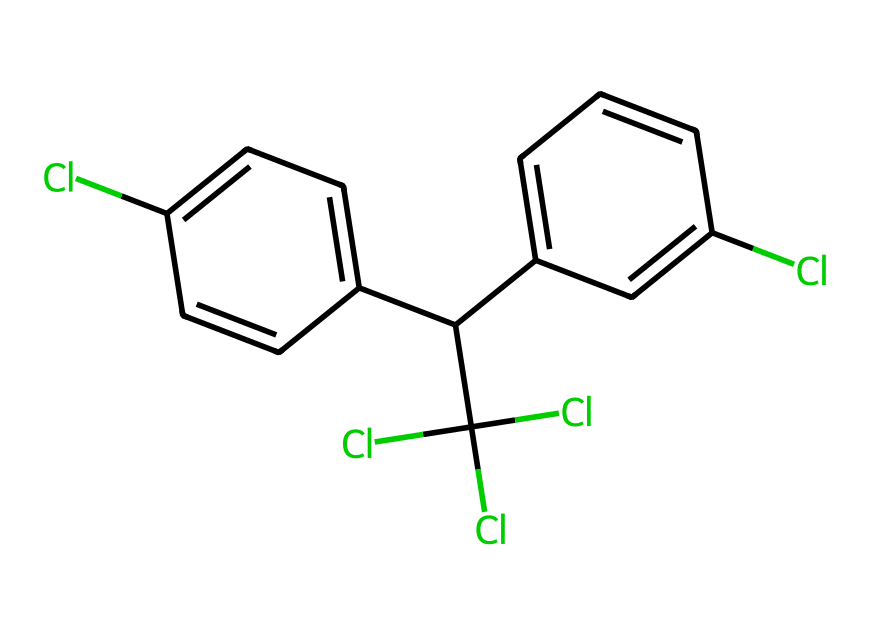What is the molecular formula of DDT? By examining the chemical structure represented in the SMILES, we identify the elements present: carbon (C), hydrogen (H), and chlorine (Cl). Counting the atoms in the structure yields a molecular formula of C14H9Cl5.
Answer: C14H9Cl5 How many chlorine atoms are in DDT? In the SMILES representation, the symbol 'Cl' appears five times, indicating the presence of five chlorine atoms in the structure.
Answer: 5 What type of compound is DDT classified as? DDT is classified as a pesticide due to its historical use in agriculture for pest control, specifically as an insecticide. Its structure supports its function as a toxic compound against insects.
Answer: pesticide How many rings are present in DDT's structure? Analyzing the structure reveals it contains two aromatic rings, which are visually recognizable through the alternating double bonds (indicated by implied structures in the SMILES).
Answer: 2 Which functional groups are present in DDT? The structure of DDT incorporates chlorinated aromatic rings but does not contain typical functional groups such as alcohols or amines. The chlorines are integral to its reactivity and properties.
Answer: chlorinated aromatic What is the significance of DDT's structure in its environmental persistence? DDT's chemical structure, particularly its chlorinated nature and absence of susceptible functional groups for degradation, contributes to its resistance to environmental breakdown, leading to its persistence in ecosystems.
Answer: persistence How does DDT relate to the category of organochlorine compounds? DDT is a member of the organochlorine class due to the presence of multiple chlorine atoms bonded to carbon atoms in its structure, which is characteristic of such compounds known for their durability and bioaccumulation.
Answer: organochlorine 